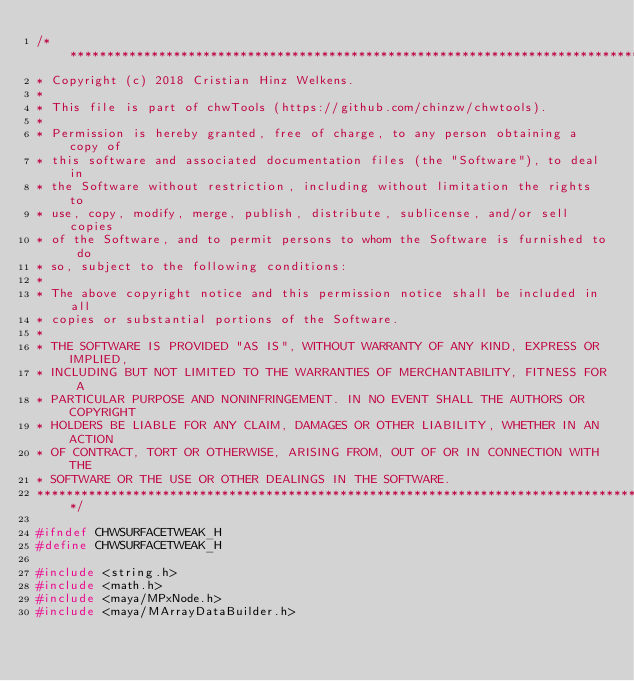<code> <loc_0><loc_0><loc_500><loc_500><_C_>/***********************************************************************************
* Copyright (c) 2018 Cristian Hinz Welkens.
*
* This file is part of chwTools (https://github.com/chinzw/chwtools).
*
* Permission is hereby granted, free of charge, to any person obtaining a copy of
* this software and associated documentation files (the "Software"), to deal in
* the Software without restriction, including without limitation the rights to 
* use, copy, modify, merge, publish, distribute, sublicense, and/or sell copies
* of the Software, and to permit persons to whom the Software is furnished to do
* so, subject to the following conditions:
*
* The above copyright notice and this permission notice shall be included in all
* copies or substantial portions of the Software.
*
* THE SOFTWARE IS PROVIDED "AS IS", WITHOUT WARRANTY OF ANY KIND, EXPRESS OR IMPLIED,
* INCLUDING BUT NOT LIMITED TO THE WARRANTIES OF MERCHANTABILITY, FITNESS FOR A
* PARTICULAR PURPOSE AND NONINFRINGEMENT. IN NO EVENT SHALL THE AUTHORS OR COPYRIGHT
* HOLDERS BE LIABLE FOR ANY CLAIM, DAMAGES OR OTHER LIABILITY, WHETHER IN AN ACTION
* OF CONTRACT, TORT OR OTHERWISE, ARISING FROM, OUT OF OR IN CONNECTION WITH THE
* SOFTWARE OR THE USE OR OTHER DEALINGS IN THE SOFTWARE.
***********************************************************************************/

#ifndef CHWSURFACETWEAK_H
#define CHWSURFACETWEAK_H

#include <string.h>
#include <math.h>
#include <maya/MPxNode.h>
#include <maya/MArrayDataBuilder.h></code> 